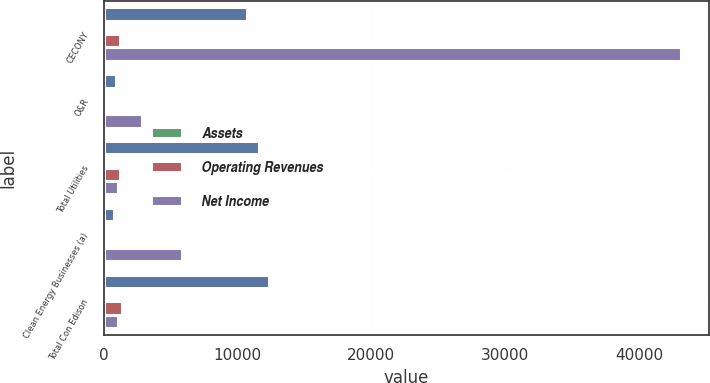<chart> <loc_0><loc_0><loc_500><loc_500><stacked_bar_chart><ecel><fcel>CECONY<fcel>O&R<fcel>Total Utilities<fcel>Clean Energy Businesses (a)<fcel>Total Con Edison<nl><fcel>nan<fcel>10680<fcel>891<fcel>11571<fcel>763<fcel>12337<nl><fcel>Assets<fcel>87<fcel>7<fcel>94<fcel>6<fcel>100<nl><fcel>Operating Revenues<fcel>1196<fcel>59<fcel>1255<fcel>145<fcel>1382<nl><fcel>Net Income<fcel>43108<fcel>2892<fcel>1043.5<fcel>5821<fcel>1043.5<nl></chart> 